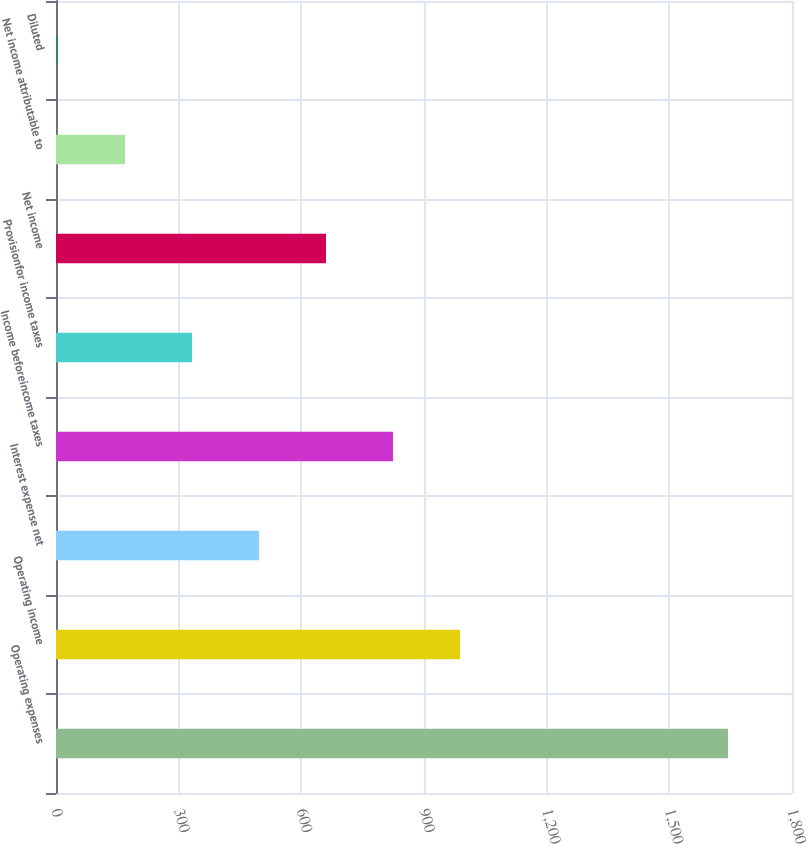Convert chart to OTSL. <chart><loc_0><loc_0><loc_500><loc_500><bar_chart><fcel>Operating expenses<fcel>Operating income<fcel>Interest expense net<fcel>Income beforeincome taxes<fcel>Provisionfor income taxes<fcel>Net income<fcel>Net income attributable to<fcel>Diluted<nl><fcel>1643.4<fcel>987.98<fcel>496.43<fcel>824.13<fcel>332.58<fcel>660.28<fcel>168.73<fcel>4.88<nl></chart> 